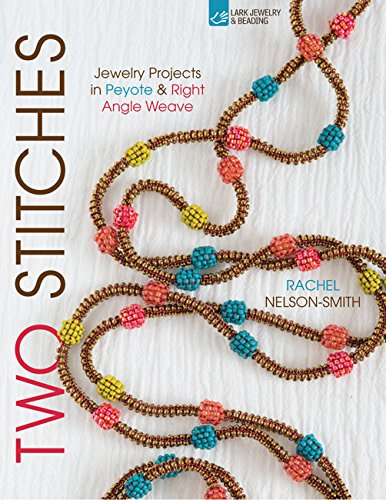What is the title of this book? The full title of the book is 'Two Stitches: Jewelry Projects in Peyote & Right Angle Weave (Bead Inspirations)', showcasing intricate projects designed to inspire jewelry makers. 